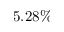Convert formula to latex. <formula><loc_0><loc_0><loc_500><loc_500>5 . 2 8 \%</formula> 